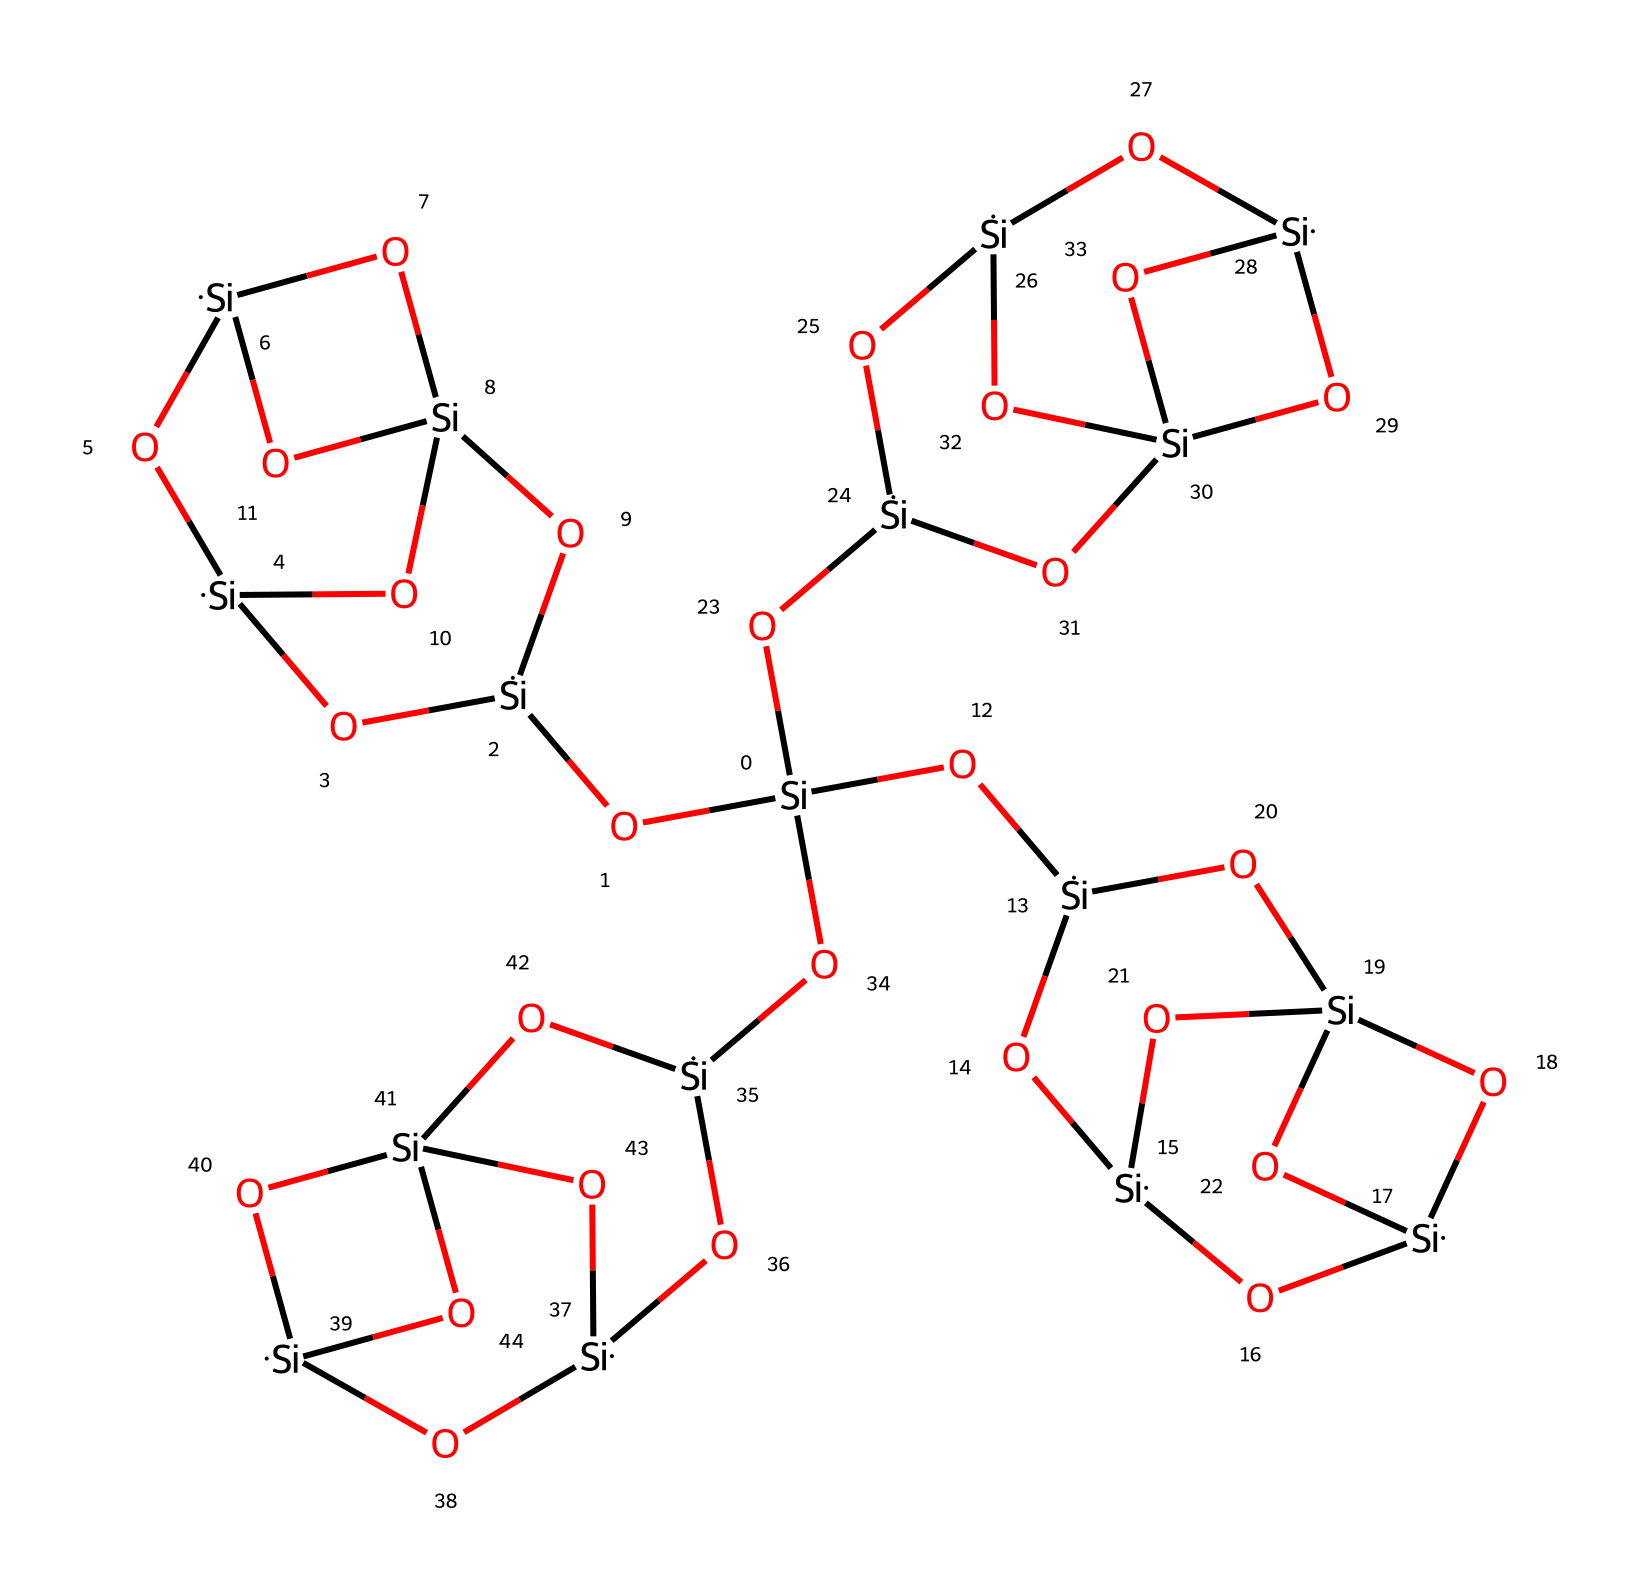What is the primary element in this silsesquioxane structure? The structure is primarily composed of silicon atoms, which can be identified as the central atoms connecting the oxygen atoms, forming a cage-like network.
Answer: silicon How many silicon atoms are present in the structure? By analyzing the SMILES representation, we can count the silicon atoms, which are denoted by the symbol "[Si]". There are eight silicon atoms in total in the provided structure.
Answer: eight What type of bonds are primarily present in this silsesquioxane cage? The primary bonds seen in this structure are silicon-oxygen bonds, which are characteristic of silsesquioxane compounds. The structural connectivity shows numerous links between silicon and oxygen.
Answer: silicon-oxygen What is the significance of the "cage" structure in this chemical? The cage structure allows for a three-dimensional network that can provide stability and potentially beneficial properties such as enhanced mechanical strength and thermal resistance, important for advanced polymer coatings.
Answer: stability How many oxygen atoms are in the silsesquioxane structure? Counting the oxygen atoms, represented by the symbol "O" in the SMILES notation, reveals that there are 12 oxygen atoms present in this particular structure.
Answer: twelve What type of chemical is silsesquioxane classified as? Silsesquioxanes are classified as hybrid organic-inorganic materials due to their silicon-oxygen framework combined with organic functional groups, which can be inferred from the multiple connectivity of silicon and oxygen in the structure.
Answer: hybrid organic-inorganic What role do the terminal silanol groups play in silsesquioxanes? Terminal silanol groups in silsesquioxanes typically provide sites for further chemical modification, influencing properties such as solubility and adhesion, which can be observed in the terminal ends of the cage structure in the SMILES representation.
Answer: chemical modification 